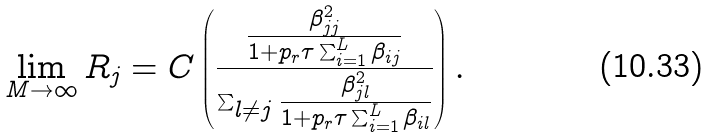<formula> <loc_0><loc_0><loc_500><loc_500>\lim _ { M \rightarrow \infty } R _ { j } = C \left ( \frac { \frac { \beta _ { j j } ^ { 2 } } { 1 + p _ { r } \tau \sum _ { i = 1 } ^ { L } \beta _ { i j } } } { \sum _ { l \ne j } \frac { \beta _ { j l } ^ { 2 } } { 1 + p _ { r } \tau \sum _ { i = 1 } ^ { L } \beta _ { i l } } } \right ) .</formula> 